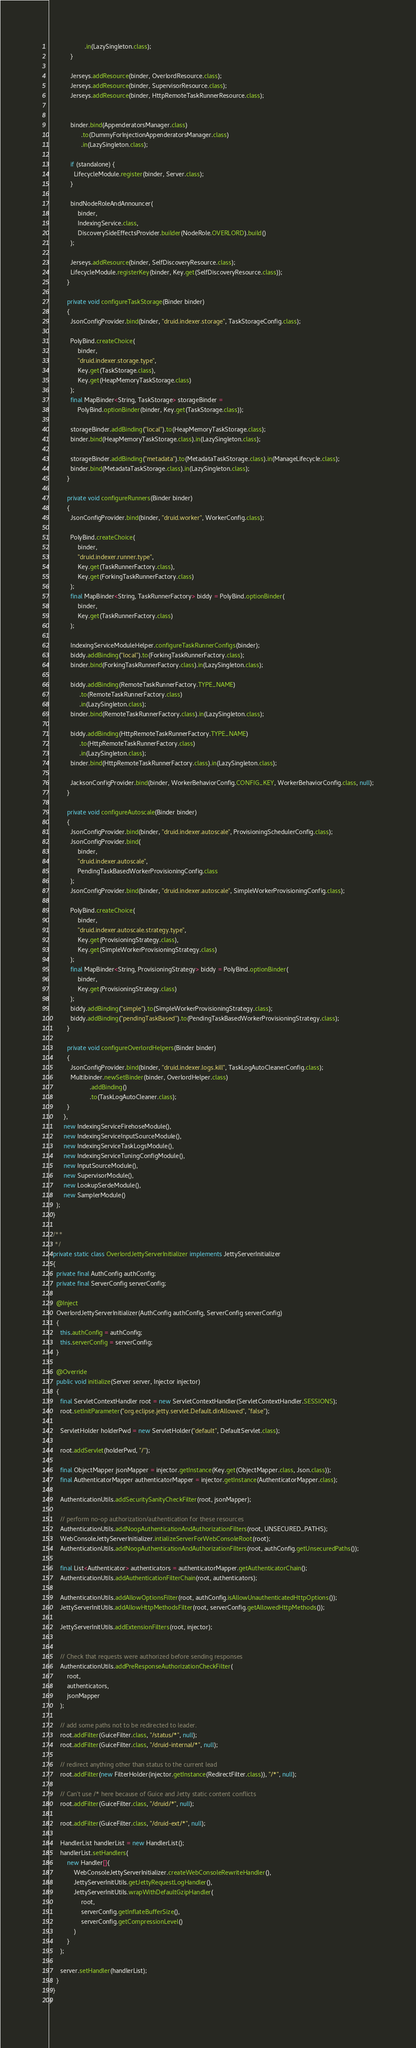<code> <loc_0><loc_0><loc_500><loc_500><_Java_>                    .in(LazySingleton.class);
            }

            Jerseys.addResource(binder, OverlordResource.class);
            Jerseys.addResource(binder, SupervisorResource.class);
            Jerseys.addResource(binder, HttpRemoteTaskRunnerResource.class);


            binder.bind(AppenderatorsManager.class)
                  .to(DummyForInjectionAppenderatorsManager.class)
                  .in(LazySingleton.class);

            if (standalone) {
              LifecycleModule.register(binder, Server.class);
            }

            bindNodeRoleAndAnnouncer(
                binder,
                IndexingService.class,
                DiscoverySideEffectsProvider.builder(NodeRole.OVERLORD).build()
            );

            Jerseys.addResource(binder, SelfDiscoveryResource.class);
            LifecycleModule.registerKey(binder, Key.get(SelfDiscoveryResource.class));
          }

          private void configureTaskStorage(Binder binder)
          {
            JsonConfigProvider.bind(binder, "druid.indexer.storage", TaskStorageConfig.class);

            PolyBind.createChoice(
                binder,
                "druid.indexer.storage.type",
                Key.get(TaskStorage.class),
                Key.get(HeapMemoryTaskStorage.class)
            );
            final MapBinder<String, TaskStorage> storageBinder =
                PolyBind.optionBinder(binder, Key.get(TaskStorage.class));

            storageBinder.addBinding("local").to(HeapMemoryTaskStorage.class);
            binder.bind(HeapMemoryTaskStorage.class).in(LazySingleton.class);

            storageBinder.addBinding("metadata").to(MetadataTaskStorage.class).in(ManageLifecycle.class);
            binder.bind(MetadataTaskStorage.class).in(LazySingleton.class);
          }

          private void configureRunners(Binder binder)
          {
            JsonConfigProvider.bind(binder, "druid.worker", WorkerConfig.class);

            PolyBind.createChoice(
                binder,
                "druid.indexer.runner.type",
                Key.get(TaskRunnerFactory.class),
                Key.get(ForkingTaskRunnerFactory.class)
            );
            final MapBinder<String, TaskRunnerFactory> biddy = PolyBind.optionBinder(
                binder,
                Key.get(TaskRunnerFactory.class)
            );

            IndexingServiceModuleHelper.configureTaskRunnerConfigs(binder);
            biddy.addBinding("local").to(ForkingTaskRunnerFactory.class);
            binder.bind(ForkingTaskRunnerFactory.class).in(LazySingleton.class);

            biddy.addBinding(RemoteTaskRunnerFactory.TYPE_NAME)
                 .to(RemoteTaskRunnerFactory.class)
                 .in(LazySingleton.class);
            binder.bind(RemoteTaskRunnerFactory.class).in(LazySingleton.class);

            biddy.addBinding(HttpRemoteTaskRunnerFactory.TYPE_NAME)
                 .to(HttpRemoteTaskRunnerFactory.class)
                 .in(LazySingleton.class);
            binder.bind(HttpRemoteTaskRunnerFactory.class).in(LazySingleton.class);

            JacksonConfigProvider.bind(binder, WorkerBehaviorConfig.CONFIG_KEY, WorkerBehaviorConfig.class, null);
          }

          private void configureAutoscale(Binder binder)
          {
            JsonConfigProvider.bind(binder, "druid.indexer.autoscale", ProvisioningSchedulerConfig.class);
            JsonConfigProvider.bind(
                binder,
                "druid.indexer.autoscale",
                PendingTaskBasedWorkerProvisioningConfig.class
            );
            JsonConfigProvider.bind(binder, "druid.indexer.autoscale", SimpleWorkerProvisioningConfig.class);

            PolyBind.createChoice(
                binder,
                "druid.indexer.autoscale.strategy.type",
                Key.get(ProvisioningStrategy.class),
                Key.get(SimpleWorkerProvisioningStrategy.class)
            );
            final MapBinder<String, ProvisioningStrategy> biddy = PolyBind.optionBinder(
                binder,
                Key.get(ProvisioningStrategy.class)
            );
            biddy.addBinding("simple").to(SimpleWorkerProvisioningStrategy.class);
            biddy.addBinding("pendingTaskBased").to(PendingTaskBasedWorkerProvisioningStrategy.class);
          }

          private void configureOverlordHelpers(Binder binder)
          {
            JsonConfigProvider.bind(binder, "druid.indexer.logs.kill", TaskLogAutoCleanerConfig.class);
            Multibinder.newSetBinder(binder, OverlordHelper.class)
                       .addBinding()
                       .to(TaskLogAutoCleaner.class);
          }
        },
        new IndexingServiceFirehoseModule(),
        new IndexingServiceInputSourceModule(),
        new IndexingServiceTaskLogsModule(),
        new IndexingServiceTuningConfigModule(),
        new InputSourceModule(),
        new SupervisorModule(),
        new LookupSerdeModule(),
        new SamplerModule()
    );
  }

  /**
   */
  private static class OverlordJettyServerInitializer implements JettyServerInitializer
  {
    private final AuthConfig authConfig;
    private final ServerConfig serverConfig;

    @Inject
    OverlordJettyServerInitializer(AuthConfig authConfig, ServerConfig serverConfig)
    {
      this.authConfig = authConfig;
      this.serverConfig = serverConfig;
    }

    @Override
    public void initialize(Server server, Injector injector)
    {
      final ServletContextHandler root = new ServletContextHandler(ServletContextHandler.SESSIONS);
      root.setInitParameter("org.eclipse.jetty.servlet.Default.dirAllowed", "false");

      ServletHolder holderPwd = new ServletHolder("default", DefaultServlet.class);

      root.addServlet(holderPwd, "/");

      final ObjectMapper jsonMapper = injector.getInstance(Key.get(ObjectMapper.class, Json.class));
      final AuthenticatorMapper authenticatorMapper = injector.getInstance(AuthenticatorMapper.class);

      AuthenticationUtils.addSecuritySanityCheckFilter(root, jsonMapper);

      // perform no-op authorization/authentication for these resources
      AuthenticationUtils.addNoopAuthenticationAndAuthorizationFilters(root, UNSECURED_PATHS);
      WebConsoleJettyServerInitializer.intializeServerForWebConsoleRoot(root);
      AuthenticationUtils.addNoopAuthenticationAndAuthorizationFilters(root, authConfig.getUnsecuredPaths());

      final List<Authenticator> authenticators = authenticatorMapper.getAuthenticatorChain();
      AuthenticationUtils.addAuthenticationFilterChain(root, authenticators);

      AuthenticationUtils.addAllowOptionsFilter(root, authConfig.isAllowUnauthenticatedHttpOptions());
      JettyServerInitUtils.addAllowHttpMethodsFilter(root, serverConfig.getAllowedHttpMethods());

      JettyServerInitUtils.addExtensionFilters(root, injector);


      // Check that requests were authorized before sending responses
      AuthenticationUtils.addPreResponseAuthorizationCheckFilter(
          root,
          authenticators,
          jsonMapper
      );

      // add some paths not to be redirected to leader.
      root.addFilter(GuiceFilter.class, "/status/*", null);
      root.addFilter(GuiceFilter.class, "/druid-internal/*", null);

      // redirect anything other than status to the current lead
      root.addFilter(new FilterHolder(injector.getInstance(RedirectFilter.class)), "/*", null);

      // Can't use /* here because of Guice and Jetty static content conflicts
      root.addFilter(GuiceFilter.class, "/druid/*", null);

      root.addFilter(GuiceFilter.class, "/druid-ext/*", null);

      HandlerList handlerList = new HandlerList();
      handlerList.setHandlers(
          new Handler[]{
              WebConsoleJettyServerInitializer.createWebConsoleRewriteHandler(),
              JettyServerInitUtils.getJettyRequestLogHandler(),
              JettyServerInitUtils.wrapWithDefaultGzipHandler(
                  root,
                  serverConfig.getInflateBufferSize(),
                  serverConfig.getCompressionLevel()
              )
          }
      );

      server.setHandler(handlerList);
    }
  }
}
</code> 